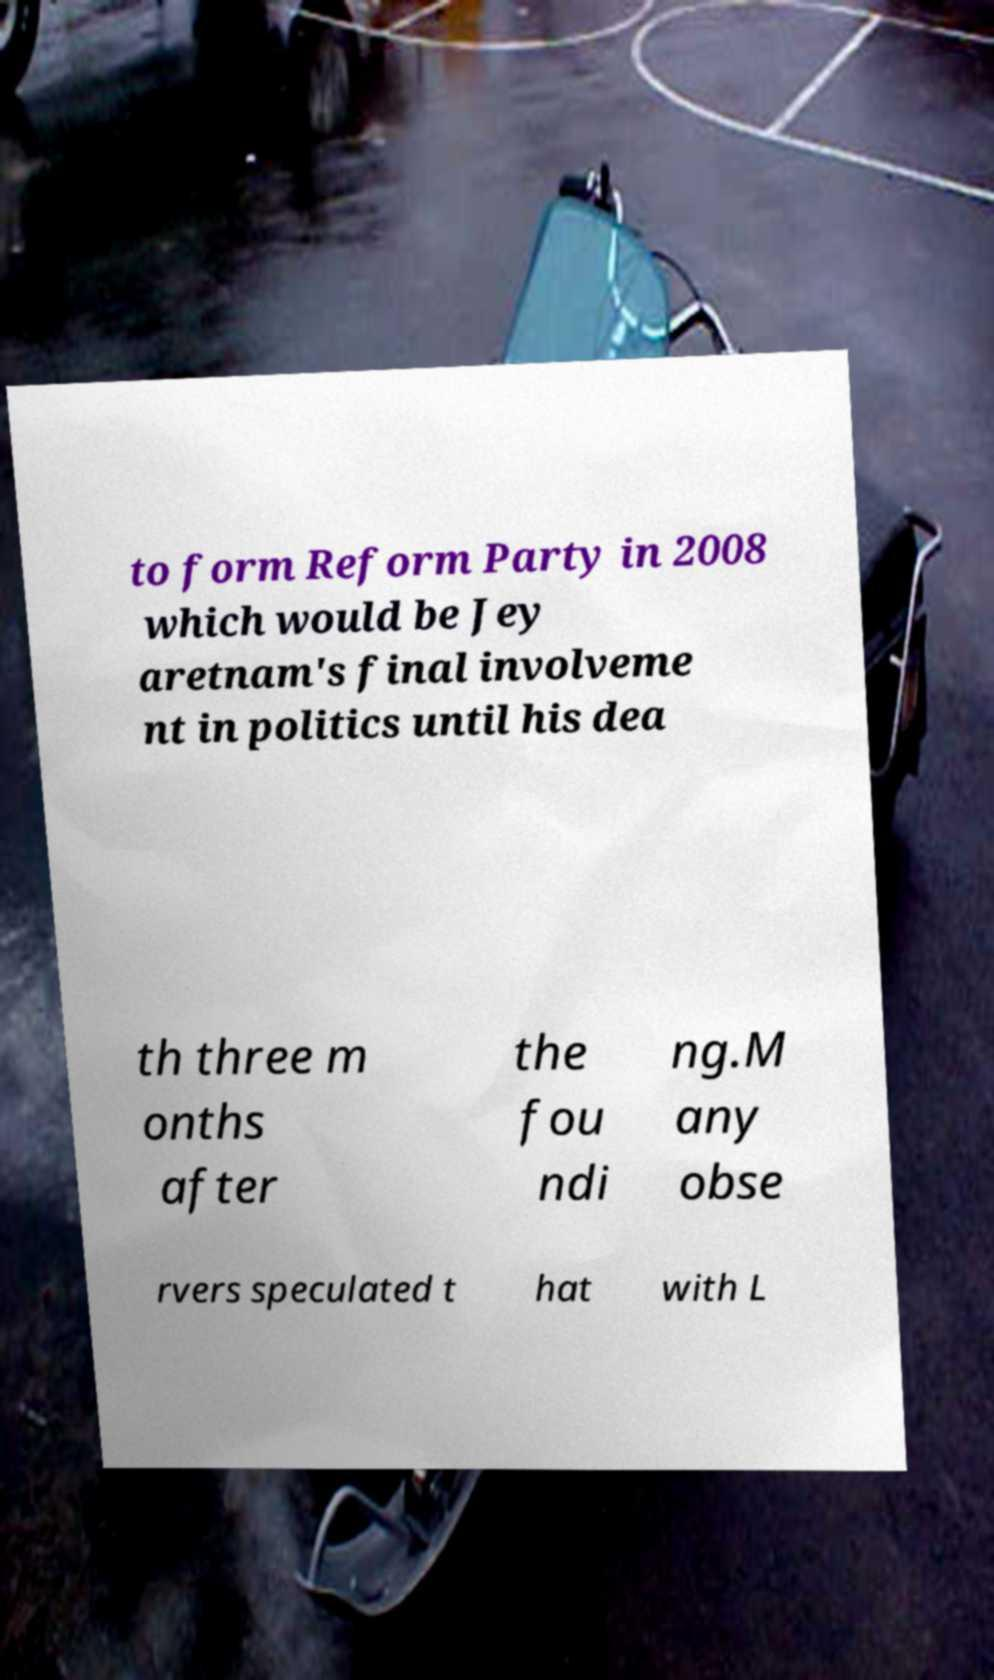What messages or text are displayed in this image? I need them in a readable, typed format. to form Reform Party in 2008 which would be Jey aretnam's final involveme nt in politics until his dea th three m onths after the fou ndi ng.M any obse rvers speculated t hat with L 